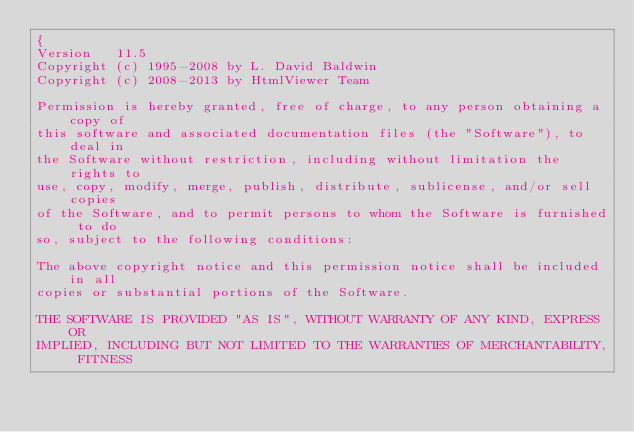<code> <loc_0><loc_0><loc_500><loc_500><_Pascal_>{
Version   11.5
Copyright (c) 1995-2008 by L. David Baldwin
Copyright (c) 2008-2013 by HtmlViewer Team

Permission is hereby granted, free of charge, to any person obtaining a copy of
this software and associated documentation files (the "Software"), to deal in
the Software without restriction, including without limitation the rights to
use, copy, modify, merge, publish, distribute, sublicense, and/or sell copies
of the Software, and to permit persons to whom the Software is furnished to do
so, subject to the following conditions:

The above copyright notice and this permission notice shall be included in all
copies or substantial portions of the Software.

THE SOFTWARE IS PROVIDED "AS IS", WITHOUT WARRANTY OF ANY KIND, EXPRESS OR
IMPLIED, INCLUDING BUT NOT LIMITED TO THE WARRANTIES OF MERCHANTABILITY, FITNESS</code> 